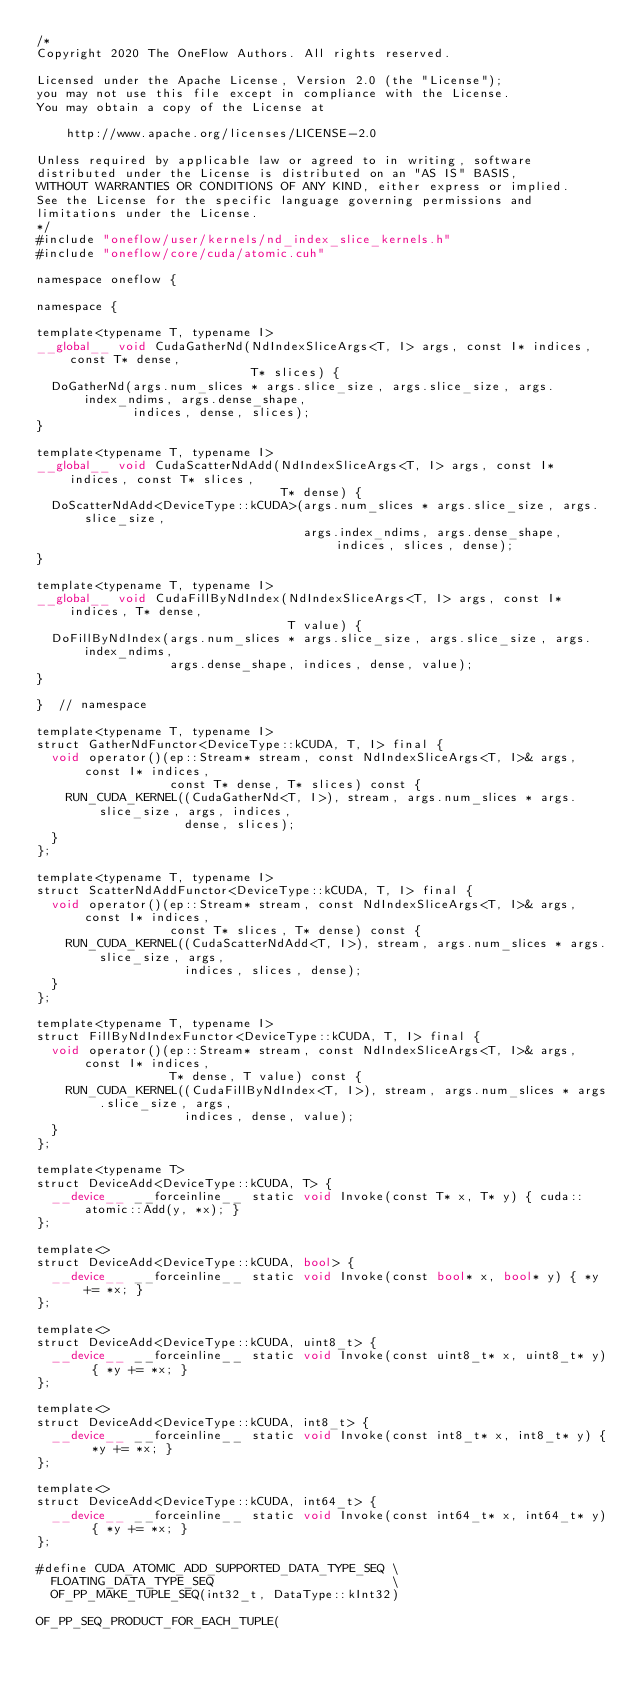<code> <loc_0><loc_0><loc_500><loc_500><_Cuda_>/*
Copyright 2020 The OneFlow Authors. All rights reserved.

Licensed under the Apache License, Version 2.0 (the "License");
you may not use this file except in compliance with the License.
You may obtain a copy of the License at

    http://www.apache.org/licenses/LICENSE-2.0

Unless required by applicable law or agreed to in writing, software
distributed under the License is distributed on an "AS IS" BASIS,
WITHOUT WARRANTIES OR CONDITIONS OF ANY KIND, either express or implied.
See the License for the specific language governing permissions and
limitations under the License.
*/
#include "oneflow/user/kernels/nd_index_slice_kernels.h"
#include "oneflow/core/cuda/atomic.cuh"

namespace oneflow {

namespace {

template<typename T, typename I>
__global__ void CudaGatherNd(NdIndexSliceArgs<T, I> args, const I* indices, const T* dense,
                             T* slices) {
  DoGatherNd(args.num_slices * args.slice_size, args.slice_size, args.index_ndims, args.dense_shape,
             indices, dense, slices);
}

template<typename T, typename I>
__global__ void CudaScatterNdAdd(NdIndexSliceArgs<T, I> args, const I* indices, const T* slices,
                                 T* dense) {
  DoScatterNdAdd<DeviceType::kCUDA>(args.num_slices * args.slice_size, args.slice_size,
                                    args.index_ndims, args.dense_shape, indices, slices, dense);
}

template<typename T, typename I>
__global__ void CudaFillByNdIndex(NdIndexSliceArgs<T, I> args, const I* indices, T* dense,
                                  T value) {
  DoFillByNdIndex(args.num_slices * args.slice_size, args.slice_size, args.index_ndims,
                  args.dense_shape, indices, dense, value);
}

}  // namespace

template<typename T, typename I>
struct GatherNdFunctor<DeviceType::kCUDA, T, I> final {
  void operator()(ep::Stream* stream, const NdIndexSliceArgs<T, I>& args, const I* indices,
                  const T* dense, T* slices) const {
    RUN_CUDA_KERNEL((CudaGatherNd<T, I>), stream, args.num_slices * args.slice_size, args, indices,
                    dense, slices);
  }
};

template<typename T, typename I>
struct ScatterNdAddFunctor<DeviceType::kCUDA, T, I> final {
  void operator()(ep::Stream* stream, const NdIndexSliceArgs<T, I>& args, const I* indices,
                  const T* slices, T* dense) const {
    RUN_CUDA_KERNEL((CudaScatterNdAdd<T, I>), stream, args.num_slices * args.slice_size, args,
                    indices, slices, dense);
  }
};

template<typename T, typename I>
struct FillByNdIndexFunctor<DeviceType::kCUDA, T, I> final {
  void operator()(ep::Stream* stream, const NdIndexSliceArgs<T, I>& args, const I* indices,
                  T* dense, T value) const {
    RUN_CUDA_KERNEL((CudaFillByNdIndex<T, I>), stream, args.num_slices * args.slice_size, args,
                    indices, dense, value);
  }
};

template<typename T>
struct DeviceAdd<DeviceType::kCUDA, T> {
  __device__ __forceinline__ static void Invoke(const T* x, T* y) { cuda::atomic::Add(y, *x); }
};

template<>
struct DeviceAdd<DeviceType::kCUDA, bool> {
  __device__ __forceinline__ static void Invoke(const bool* x, bool* y) { *y += *x; }
};

template<>
struct DeviceAdd<DeviceType::kCUDA, uint8_t> {
  __device__ __forceinline__ static void Invoke(const uint8_t* x, uint8_t* y) { *y += *x; }
};

template<>
struct DeviceAdd<DeviceType::kCUDA, int8_t> {
  __device__ __forceinline__ static void Invoke(const int8_t* x, int8_t* y) { *y += *x; }
};

template<>
struct DeviceAdd<DeviceType::kCUDA, int64_t> {
  __device__ __forceinline__ static void Invoke(const int64_t* x, int64_t* y) { *y += *x; }
};

#define CUDA_ATOMIC_ADD_SUPPORTED_DATA_TYPE_SEQ \
  FLOATING_DATA_TYPE_SEQ                        \
  OF_PP_MAKE_TUPLE_SEQ(int32_t, DataType::kInt32)

OF_PP_SEQ_PRODUCT_FOR_EACH_TUPLE(</code> 